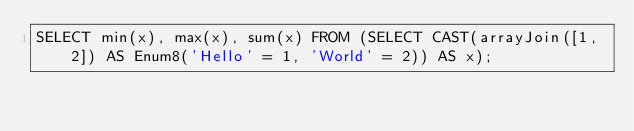<code> <loc_0><loc_0><loc_500><loc_500><_SQL_>SELECT min(x), max(x), sum(x) FROM (SELECT CAST(arrayJoin([1, 2]) AS Enum8('Hello' = 1, 'World' = 2)) AS x);
</code> 